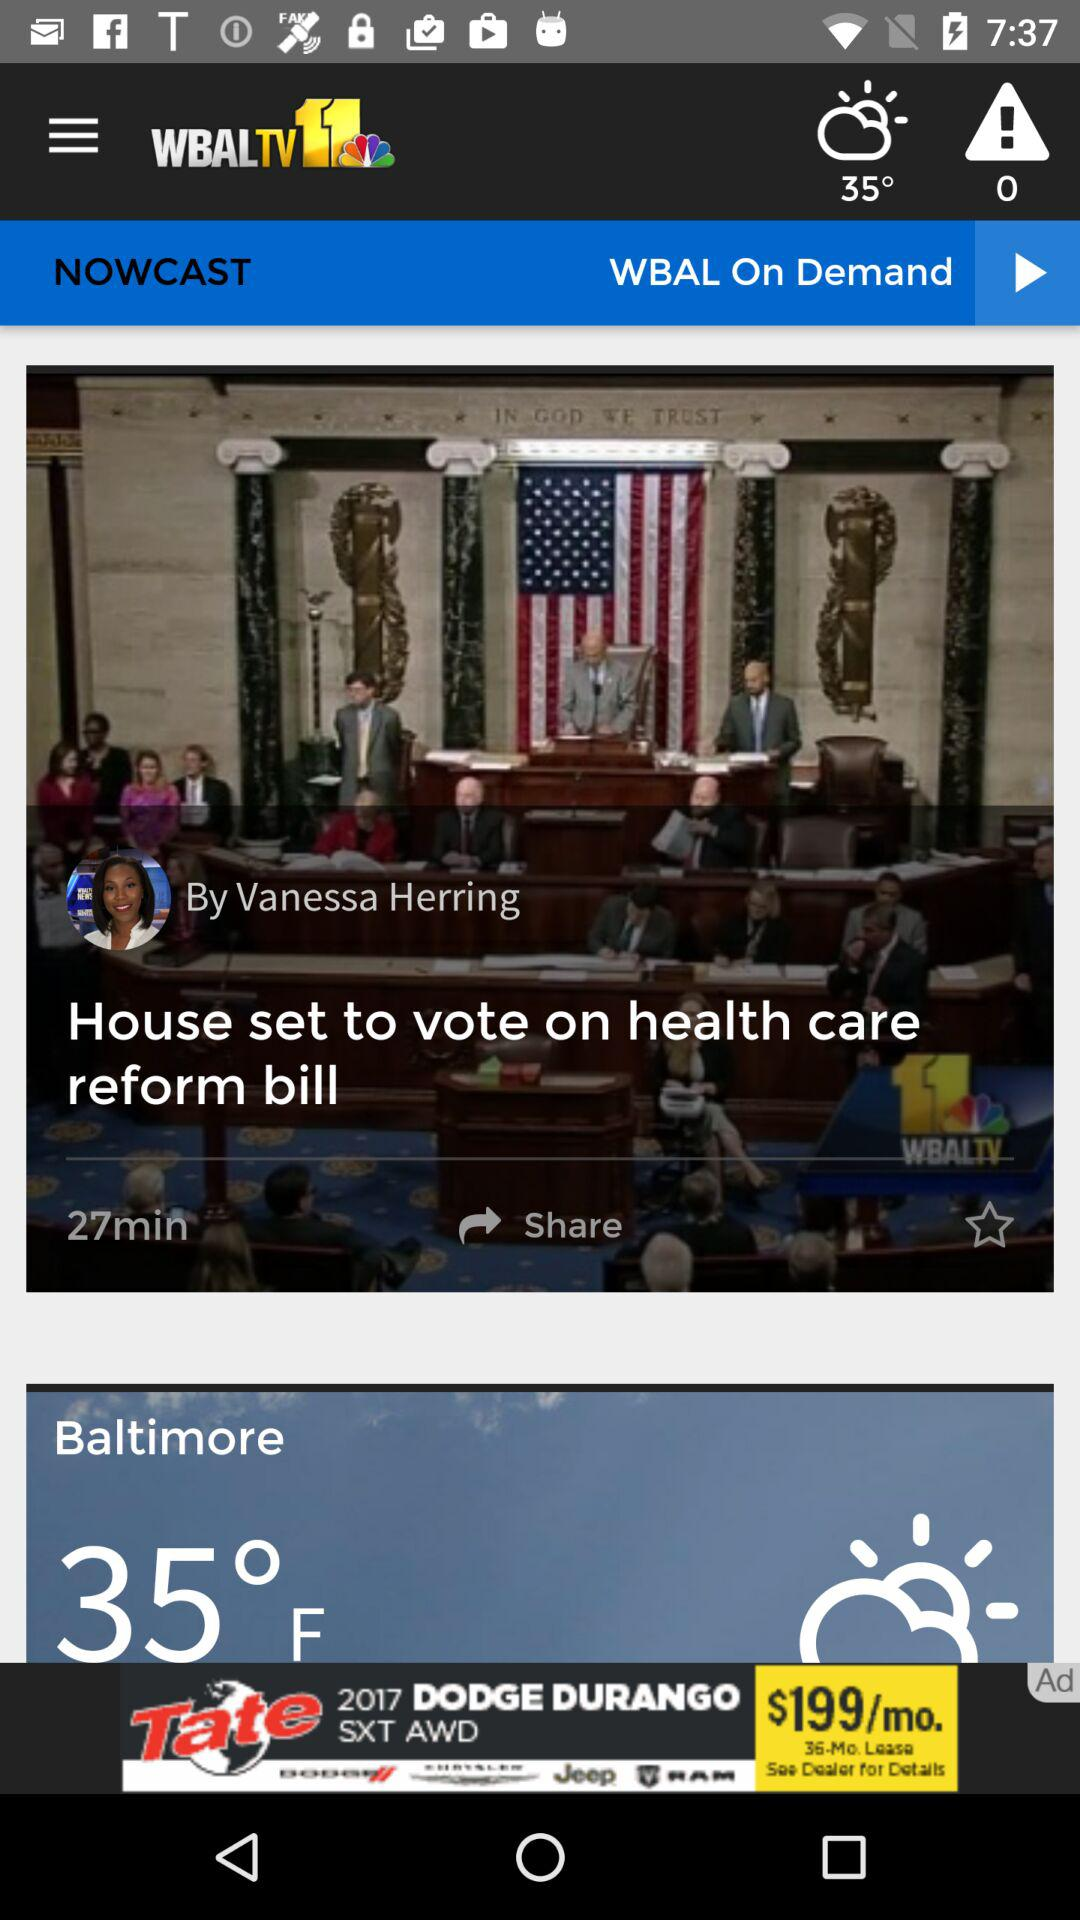What is the temperature? The temperatures are 35° and 35 °F. 